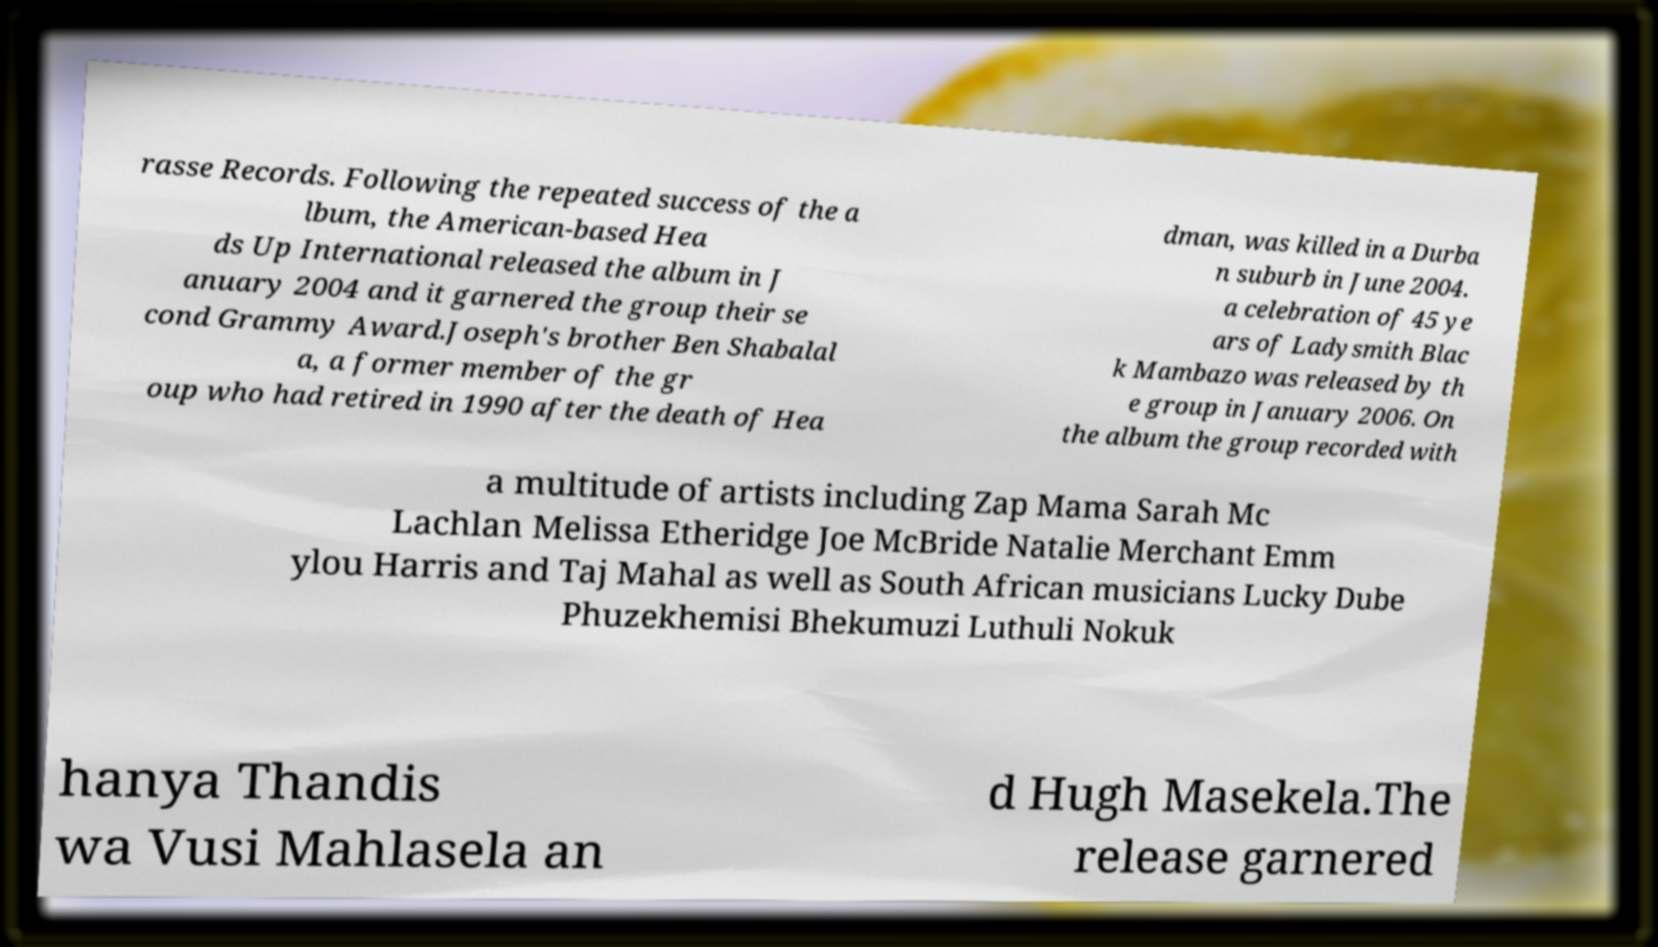What messages or text are displayed in this image? I need them in a readable, typed format. rasse Records. Following the repeated success of the a lbum, the American-based Hea ds Up International released the album in J anuary 2004 and it garnered the group their se cond Grammy Award.Joseph's brother Ben Shabalal a, a former member of the gr oup who had retired in 1990 after the death of Hea dman, was killed in a Durba n suburb in June 2004. a celebration of 45 ye ars of Ladysmith Blac k Mambazo was released by th e group in January 2006. On the album the group recorded with a multitude of artists including Zap Mama Sarah Mc Lachlan Melissa Etheridge Joe McBride Natalie Merchant Emm ylou Harris and Taj Mahal as well as South African musicians Lucky Dube Phuzekhemisi Bhekumuzi Luthuli Nokuk hanya Thandis wa Vusi Mahlasela an d Hugh Masekela.The release garnered 